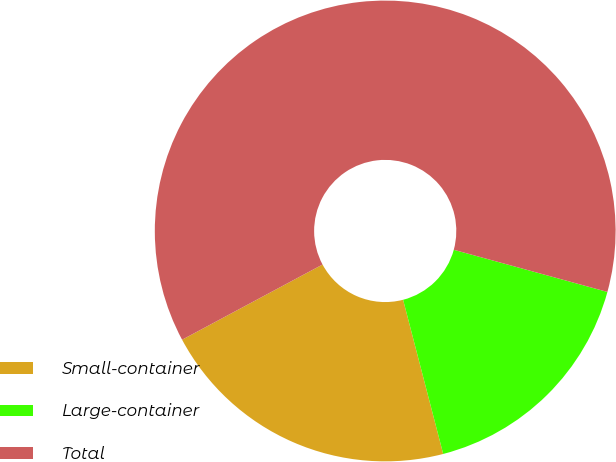<chart> <loc_0><loc_0><loc_500><loc_500><pie_chart><fcel>Small-container<fcel>Large-container<fcel>Total<nl><fcel>21.23%<fcel>16.69%<fcel>62.09%<nl></chart> 